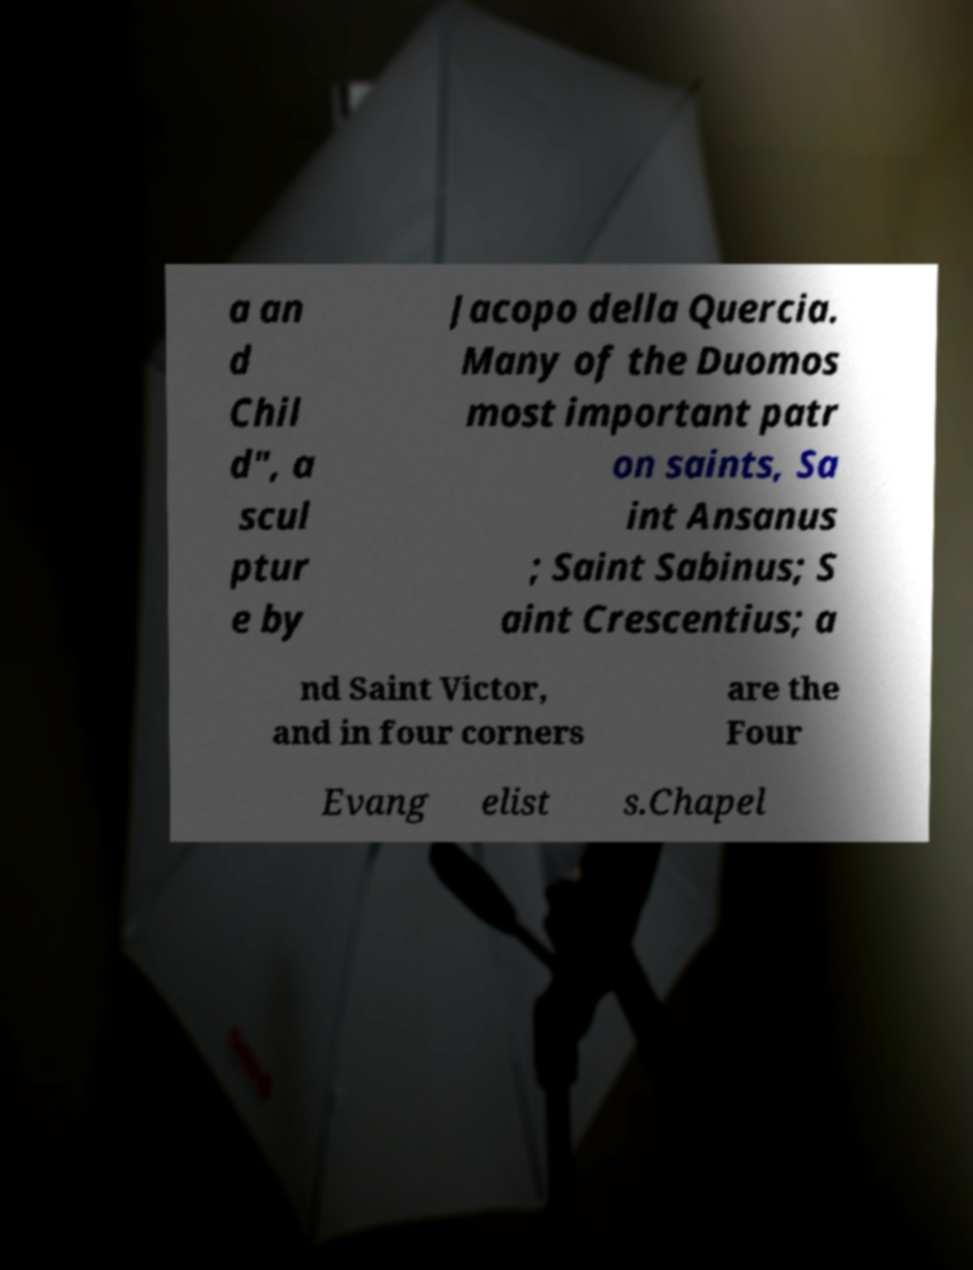Can you accurately transcribe the text from the provided image for me? a an d Chil d", a scul ptur e by Jacopo della Quercia. Many of the Duomos most important patr on saints, Sa int Ansanus ; Saint Sabinus; S aint Crescentius; a nd Saint Victor, and in four corners are the Four Evang elist s.Chapel 